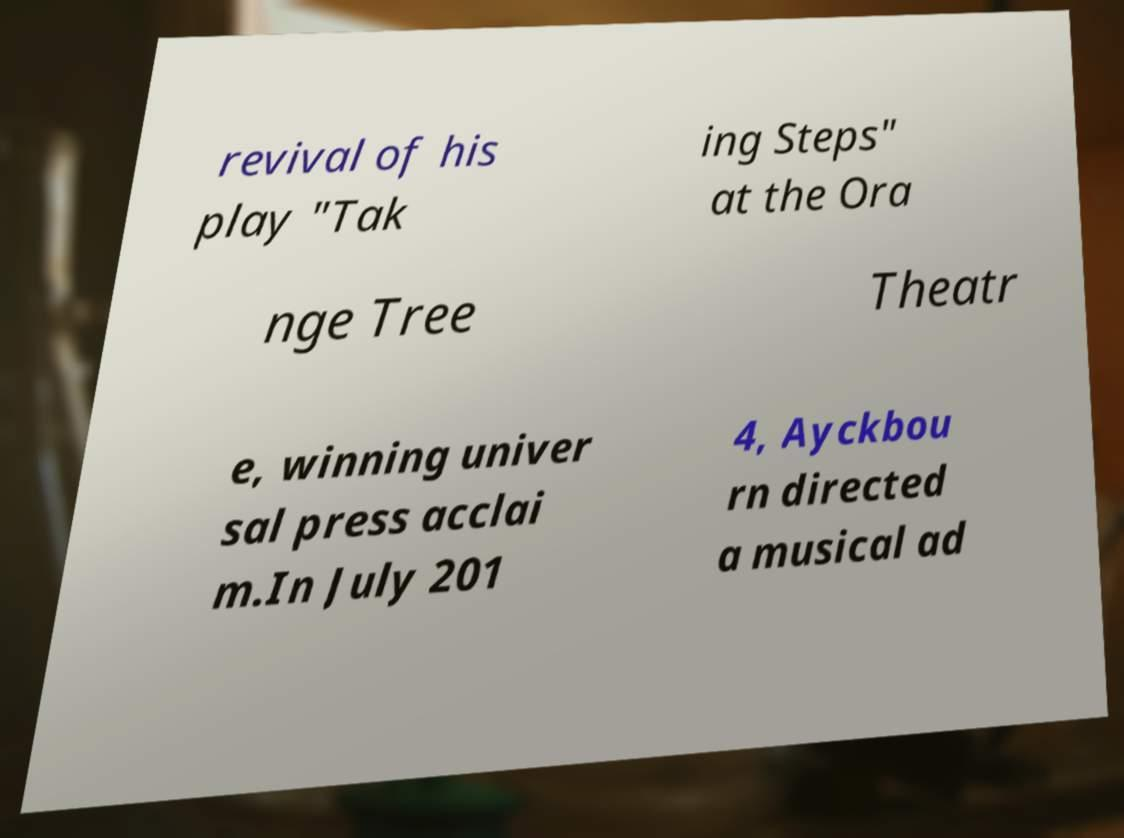What messages or text are displayed in this image? I need them in a readable, typed format. revival of his play "Tak ing Steps" at the Ora nge Tree Theatr e, winning univer sal press acclai m.In July 201 4, Ayckbou rn directed a musical ad 